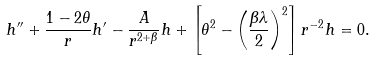Convert formula to latex. <formula><loc_0><loc_0><loc_500><loc_500>h ^ { \prime \prime } + \frac { 1 - 2 \theta } { r } h ^ { \prime } - \frac { A } { r ^ { 2 + \beta } } h + \left [ \theta ^ { 2 } - \left ( \frac { \beta \lambda } { 2 } \right ) ^ { 2 } \right ] r ^ { - 2 } h = 0 .</formula> 